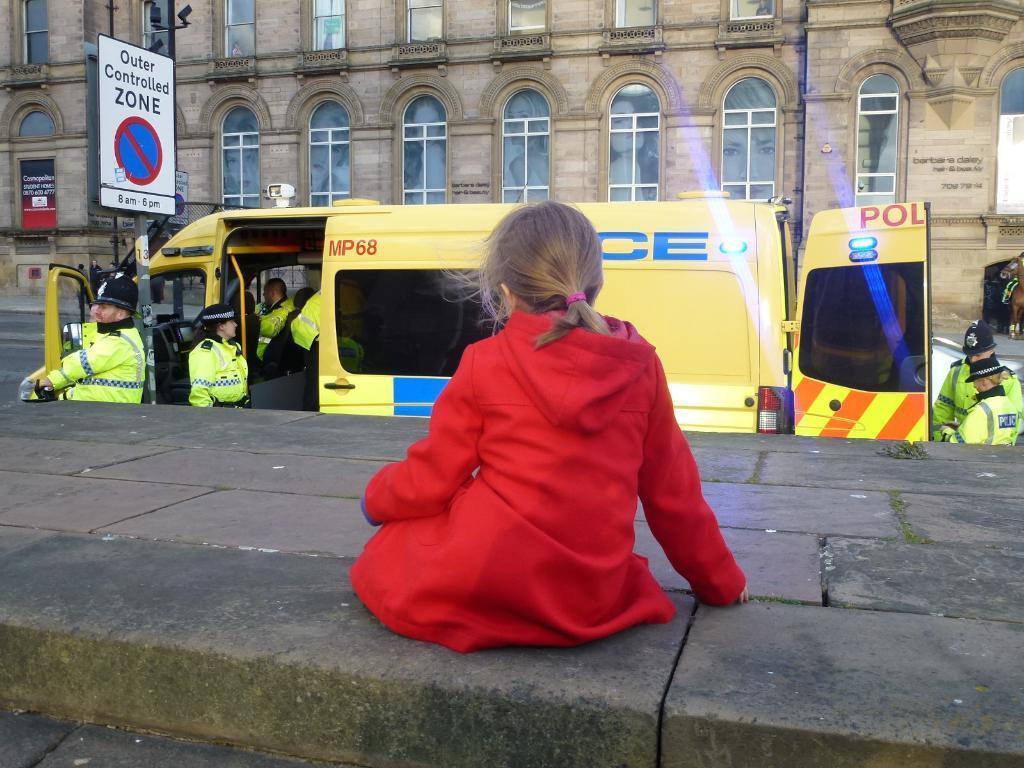How would you summarize this image in a sentence or two? In the foreground of this image, there is a girl and it seems like she is sitting on a pavement. In the middle, there is a vehicle and a board. We can see few people are inside it and few are standing outside of it. In the background, there is a building and the road. 